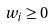Convert formula to latex. <formula><loc_0><loc_0><loc_500><loc_500>w _ { i } \geq 0</formula> 